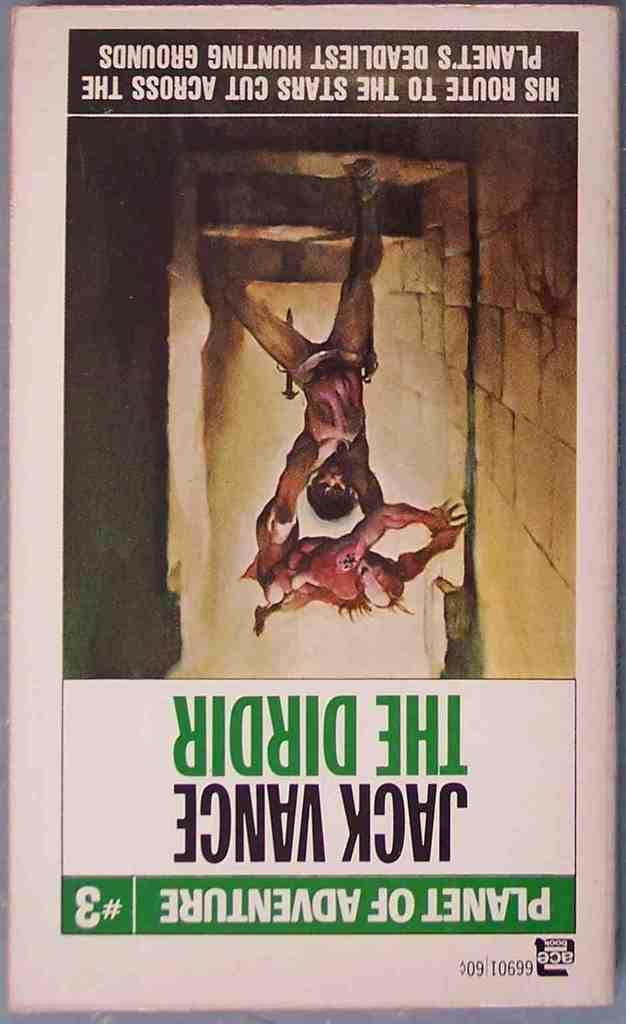<image>
Write a terse but informative summary of the picture. The cover of a comic book which reads Planet of Adventure #3. 